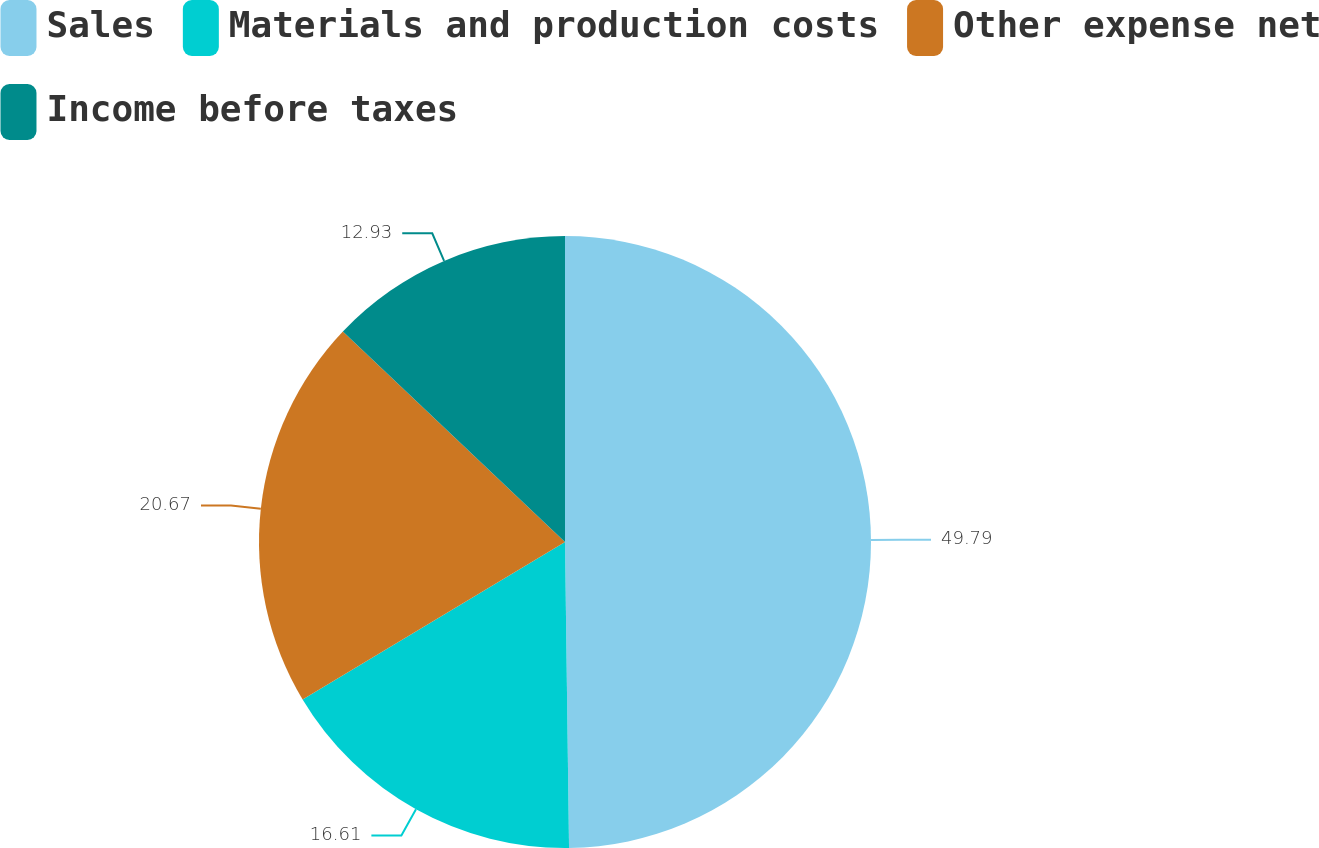<chart> <loc_0><loc_0><loc_500><loc_500><pie_chart><fcel>Sales<fcel>Materials and production costs<fcel>Other expense net<fcel>Income before taxes<nl><fcel>49.79%<fcel>16.61%<fcel>20.67%<fcel>12.93%<nl></chart> 